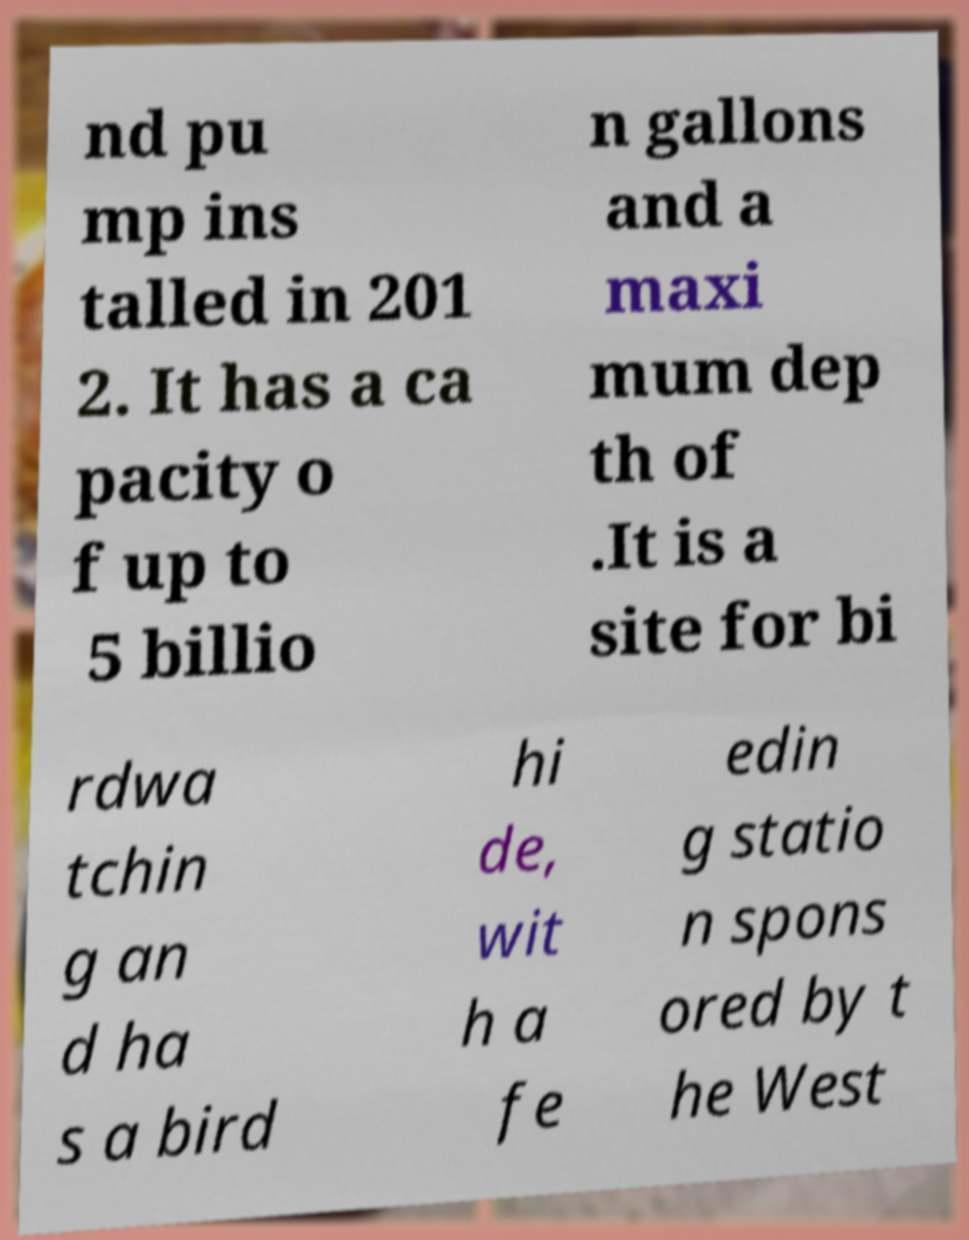Could you assist in decoding the text presented in this image and type it out clearly? nd pu mp ins talled in 201 2. It has a ca pacity o f up to 5 billio n gallons and a maxi mum dep th of .It is a site for bi rdwa tchin g an d ha s a bird hi de, wit h a fe edin g statio n spons ored by t he West 